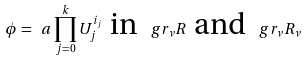<formula> <loc_0><loc_0><loc_500><loc_500>\phi = \ a \prod _ { j = 0 } ^ { k } U _ { j } ^ { i _ { j } } \ \text {in} \ \ g r _ { \nu } R \ \text {and} \ \ g r _ { \nu } R _ { \nu }</formula> 